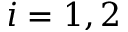<formula> <loc_0><loc_0><loc_500><loc_500>i = 1 , 2</formula> 